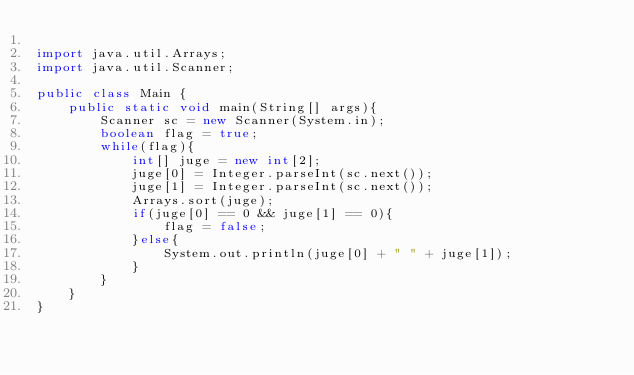<code> <loc_0><loc_0><loc_500><loc_500><_Java_>
import java.util.Arrays;
import java.util.Scanner;

public class Main {
    public static void main(String[] args){
        Scanner sc = new Scanner(System.in);
        boolean flag = true;
        while(flag){
            int[] juge = new int[2];
            juge[0] = Integer.parseInt(sc.next());
            juge[1] = Integer.parseInt(sc.next());
            Arrays.sort(juge);
            if(juge[0] == 0 && juge[1] == 0){
                flag = false;
            }else{
                System.out.println(juge[0] + " " + juge[1]);                
            }
        }
    }
}
</code> 